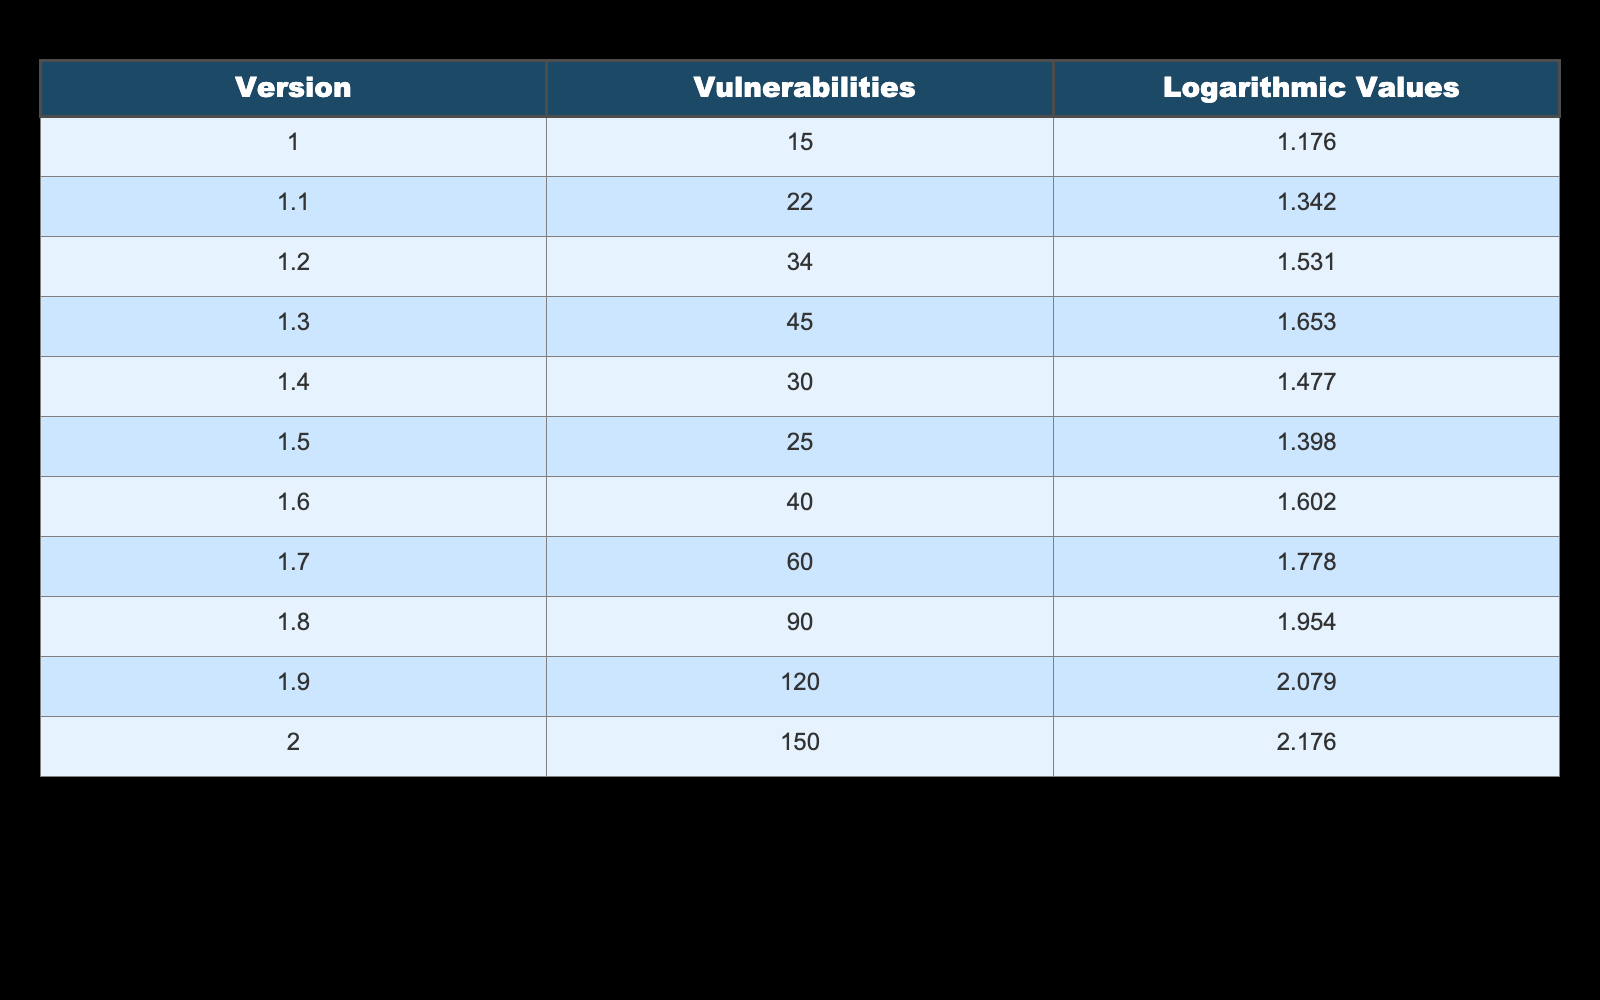What is the version with the highest number of vulnerabilities? Looking at the table, the vulnerabilities column shows that version 2.0 has 150 vulnerabilities, which is the highest value compared to other versions.
Answer: 2.0 What is the logarithmic value for version 1.5? The logarithmic values column relevant to version 1.5 shows a value of 1.398. This can be directly observed in the table.
Answer: 1.398 Is there a decrease in the number of vulnerabilities from version 1.4 to 1.5? Yes, from version 1.4 to 1.5, the vulnerabilities decreased from 30 to 25. This shows a direct decline in numbers.
Answer: Yes What is the average number of vulnerabilities across all versions? To find the average, we sum all vulnerabilities: (15 + 22 + 34 + 45 + 30 + 25 + 40 + 60 + 90 + 120 + 150) = 570. Then, we divide by the number of versions (11): 570 / 11 = 51.82.
Answer: 51.82 Are there more than 70 vulnerabilities in version 1.8? No, version 1.8 has 90 vulnerabilities, which is more than 70. Thus, the statement is true upon verification with the data.
Answer: Yes What is the difference in vulnerabilities between version 1.2 and version 1.1? The difference is calculated by subtracting the number of vulnerabilities in version 1.1 from that of version 1.2: 34 - 22 = 12.
Answer: 12 What version shows the lowest logarithmic value? The logarithmic values show that version 1.0 has the lowest value of 1.176. This can be seen directly in the table.
Answer: 1.0 How many vulnerabilities were identified in version 1.7 compared to version 1.6? Version 1.7 has 60 vulnerabilities while version 1.6 has 40. The difference is calculated as 60 - 40 = 20.
Answer: 20 What is the total number of vulnerabilities from versions 1.0 to 1.3? The total for versions 1.0 to 1.3 is found by summing up their vulnerabilities: 15 (1.0) + 22 (1.1) + 34 (1.2) + 45 (1.3) = 116.
Answer: 116 